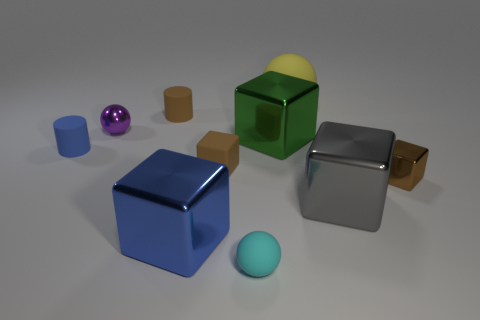Does the large green cube have the same material as the large sphere?
Provide a succinct answer. No. What is the size of the blue object that is the same shape as the large green metal thing?
Your answer should be compact. Large. How many things are brown rubber objects that are behind the green block or brown blocks to the right of the tiny cyan object?
Ensure brevity in your answer.  2. Is the number of tiny brown things less than the number of big purple metallic cylinders?
Offer a very short reply. No. There is a cyan rubber thing; is it the same size as the block that is behind the small blue matte thing?
Your response must be concise. No. What number of metal objects are tiny blue objects or cylinders?
Provide a short and direct response. 0. Are there more big blue metallic cubes than small yellow matte cubes?
Your answer should be very brief. Yes. The rubber cylinder that is the same color as the tiny rubber cube is what size?
Offer a very short reply. Small. What is the shape of the tiny blue thing that is left of the rubber ball that is in front of the large yellow rubber sphere?
Ensure brevity in your answer.  Cylinder. Is there a brown rubber block that is in front of the big thing that is on the left side of the cyan thing in front of the purple shiny sphere?
Your response must be concise. No. 